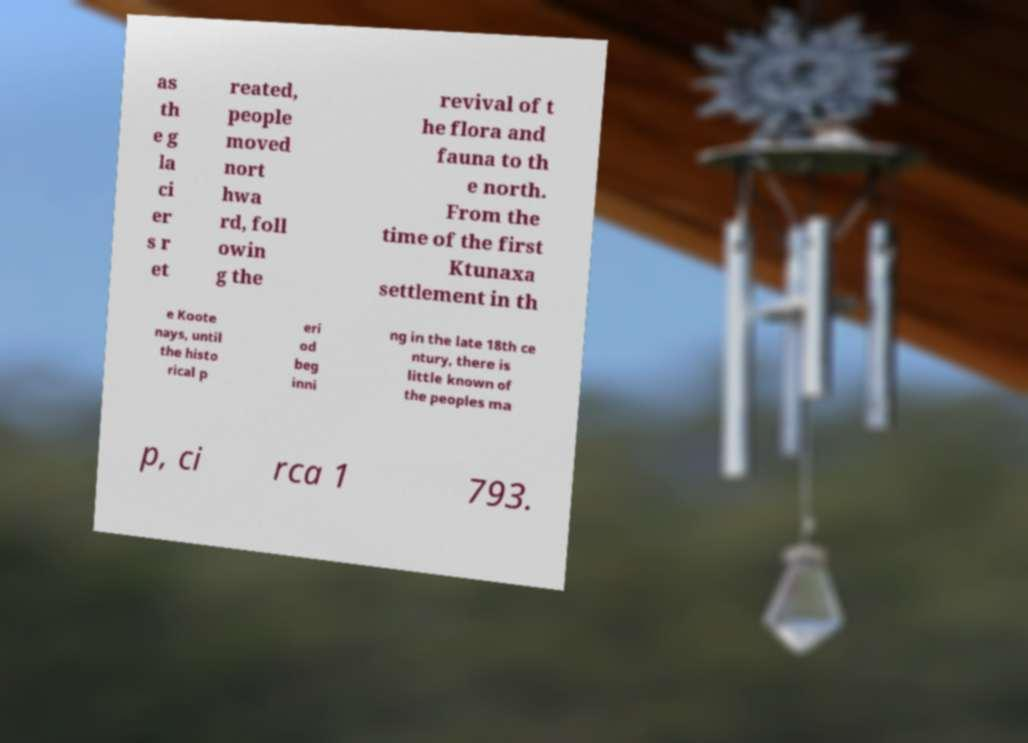For documentation purposes, I need the text within this image transcribed. Could you provide that? as th e g la ci er s r et reated, people moved nort hwa rd, foll owin g the revival of t he flora and fauna to th e north. From the time of the first Ktunaxa settlement in th e Koote nays, until the histo rical p eri od beg inni ng in the late 18th ce ntury, there is little known of the peoples ma p, ci rca 1 793. 